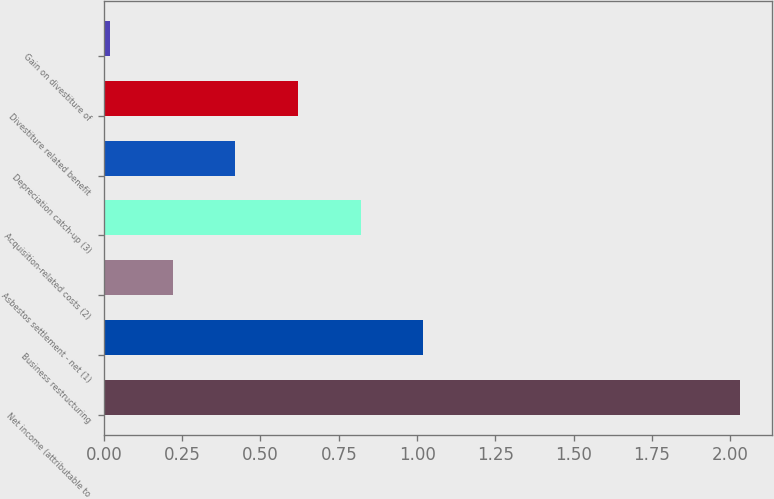Convert chart. <chart><loc_0><loc_0><loc_500><loc_500><bar_chart><fcel>Net income (attributable to<fcel>Business restructuring<fcel>Asbestos settlement - net (1)<fcel>Acquisition-related costs (2)<fcel>Depreciation catch-up (3)<fcel>Divestiture related benefit<fcel>Gain on divestiture of<nl><fcel>2.03<fcel>1.02<fcel>0.22<fcel>0.82<fcel>0.42<fcel>0.62<fcel>0.02<nl></chart> 